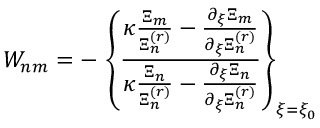<formula> <loc_0><loc_0><loc_500><loc_500>W _ { n m } = - \, \left \{ \frac { \kappa \frac { \Xi _ { m } } { \Xi _ { n } ^ { ( r ) } } - \frac { \partial _ { \xi } \Xi _ { m } } { \partial _ { \xi } \Xi _ { n } ^ { ( r ) } } } { \kappa \frac { \Xi _ { n } } { \Xi _ { n } ^ { ( r ) } } - \frac { \partial _ { \xi } \Xi _ { n } } { \partial _ { \xi } \Xi _ { n } ^ { ( r ) } } } \right \} _ { \xi = \xi _ { 0 } }</formula> 